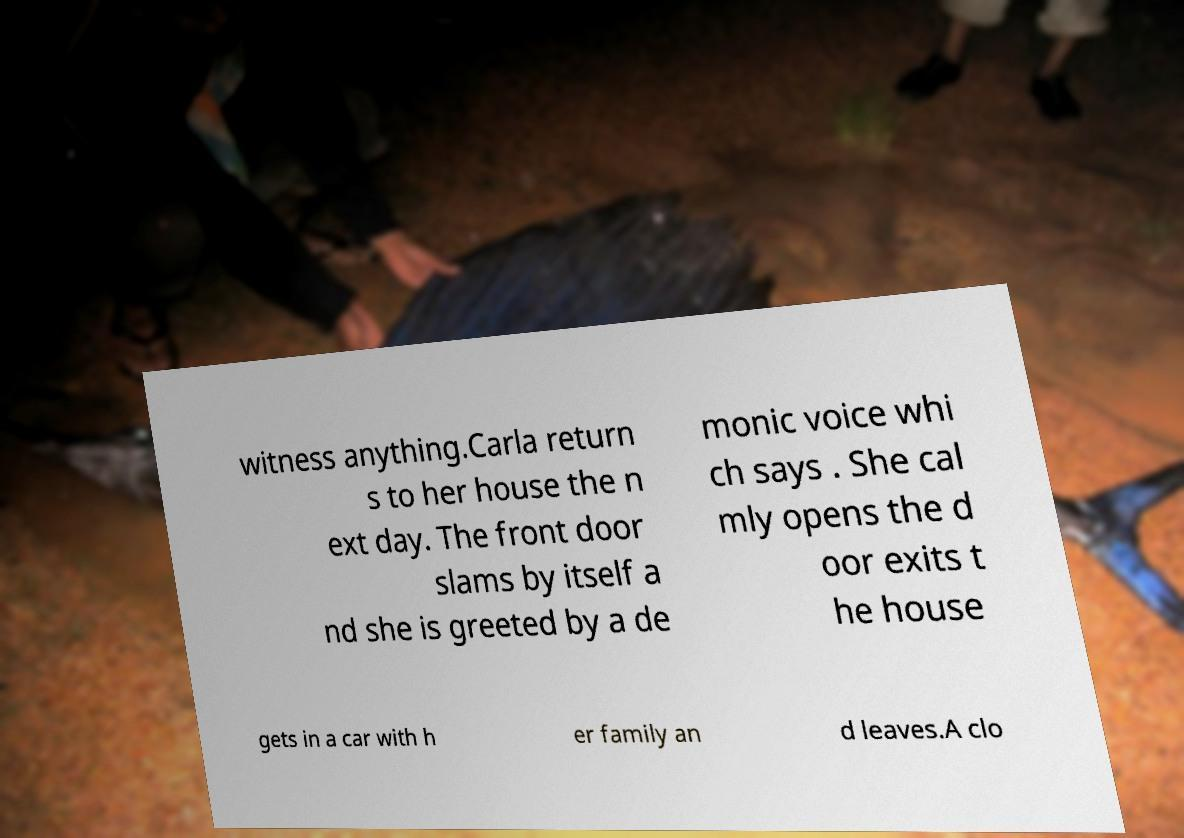Please read and relay the text visible in this image. What does it say? witness anything.Carla return s to her house the n ext day. The front door slams by itself a nd she is greeted by a de monic voice whi ch says . She cal mly opens the d oor exits t he house gets in a car with h er family an d leaves.A clo 